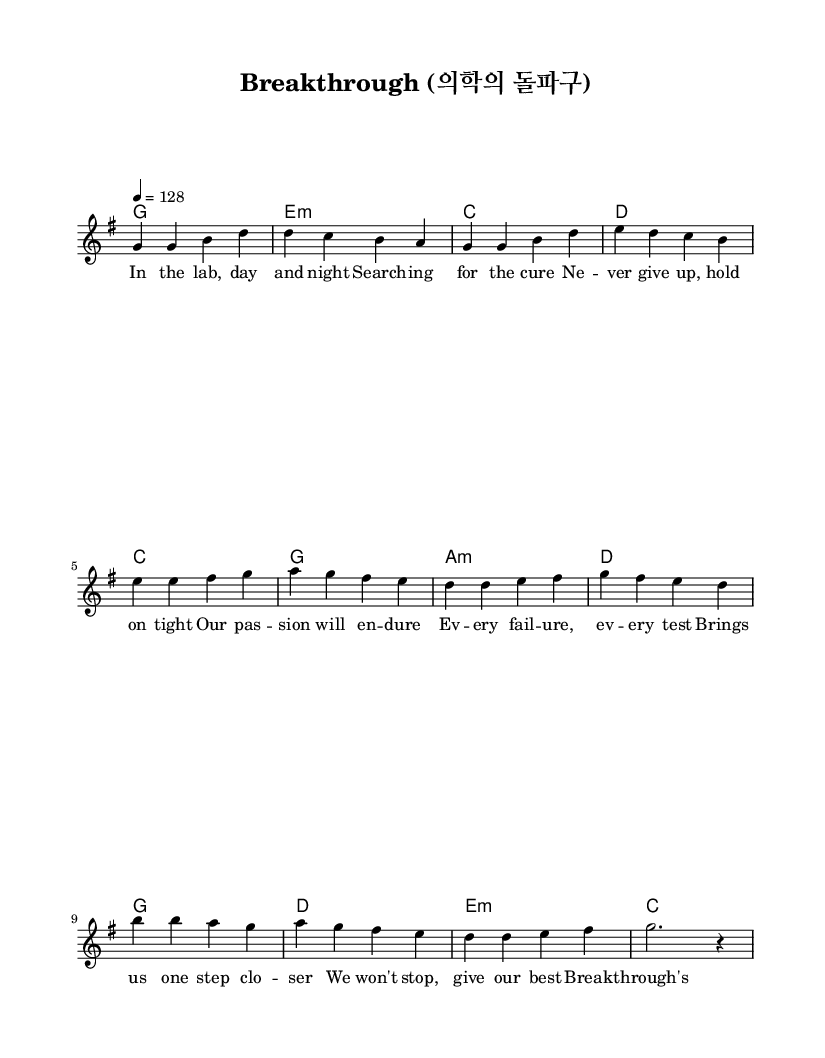What is the key signature of this music? The key signature is G major, which includes one sharp (F#). This can be determined by looking at the key signature marked at the beginning of the music.
Answer: G major What is the time signature of this music? The time signature is 4/4, indicated at the beginning of the sheet music. This means there are four beats in each measure, and the quarter note receives one beat.
Answer: 4/4 What is the tempo marking for this piece? The tempo is marked as 4 = 128, which means that there are 128 beats per minute (bpm), corresponding to quarter notes. This is found in the tempo marking provided in the score.
Answer: 128 How many measures are in the verse section? The verse section consists of four measures, which can be counted by examining the music notation where the melody and harmonies are indicated for the verse.
Answer: 4 What does the chorus emphasize in its lyrics? The chorus emphasizes perseverance and dedication, which is highlighted by the lyrics that include the words "persevere" and "dedicate." This thematic focus can be identified in the lyrics displayed for the chorus section.
Answer: Perseverance How many chords are used in the pre-chorus? The pre-chorus uses four distinct chords, as shown in the chord progression for that section. You can see the chord symbols written above the melody notes corresponding to the pre-chorus lyrics.
Answer: 4 What K-Pop thematic element is present in the lyrics? The thematic element present is the pursuit of medical advancements through research and dedication, reflected in the encouraging lyrics related to overcoming challenges in a lab setting. This is derived from the overall message conveyed in the song.
Answer: Perseverance and dedication 